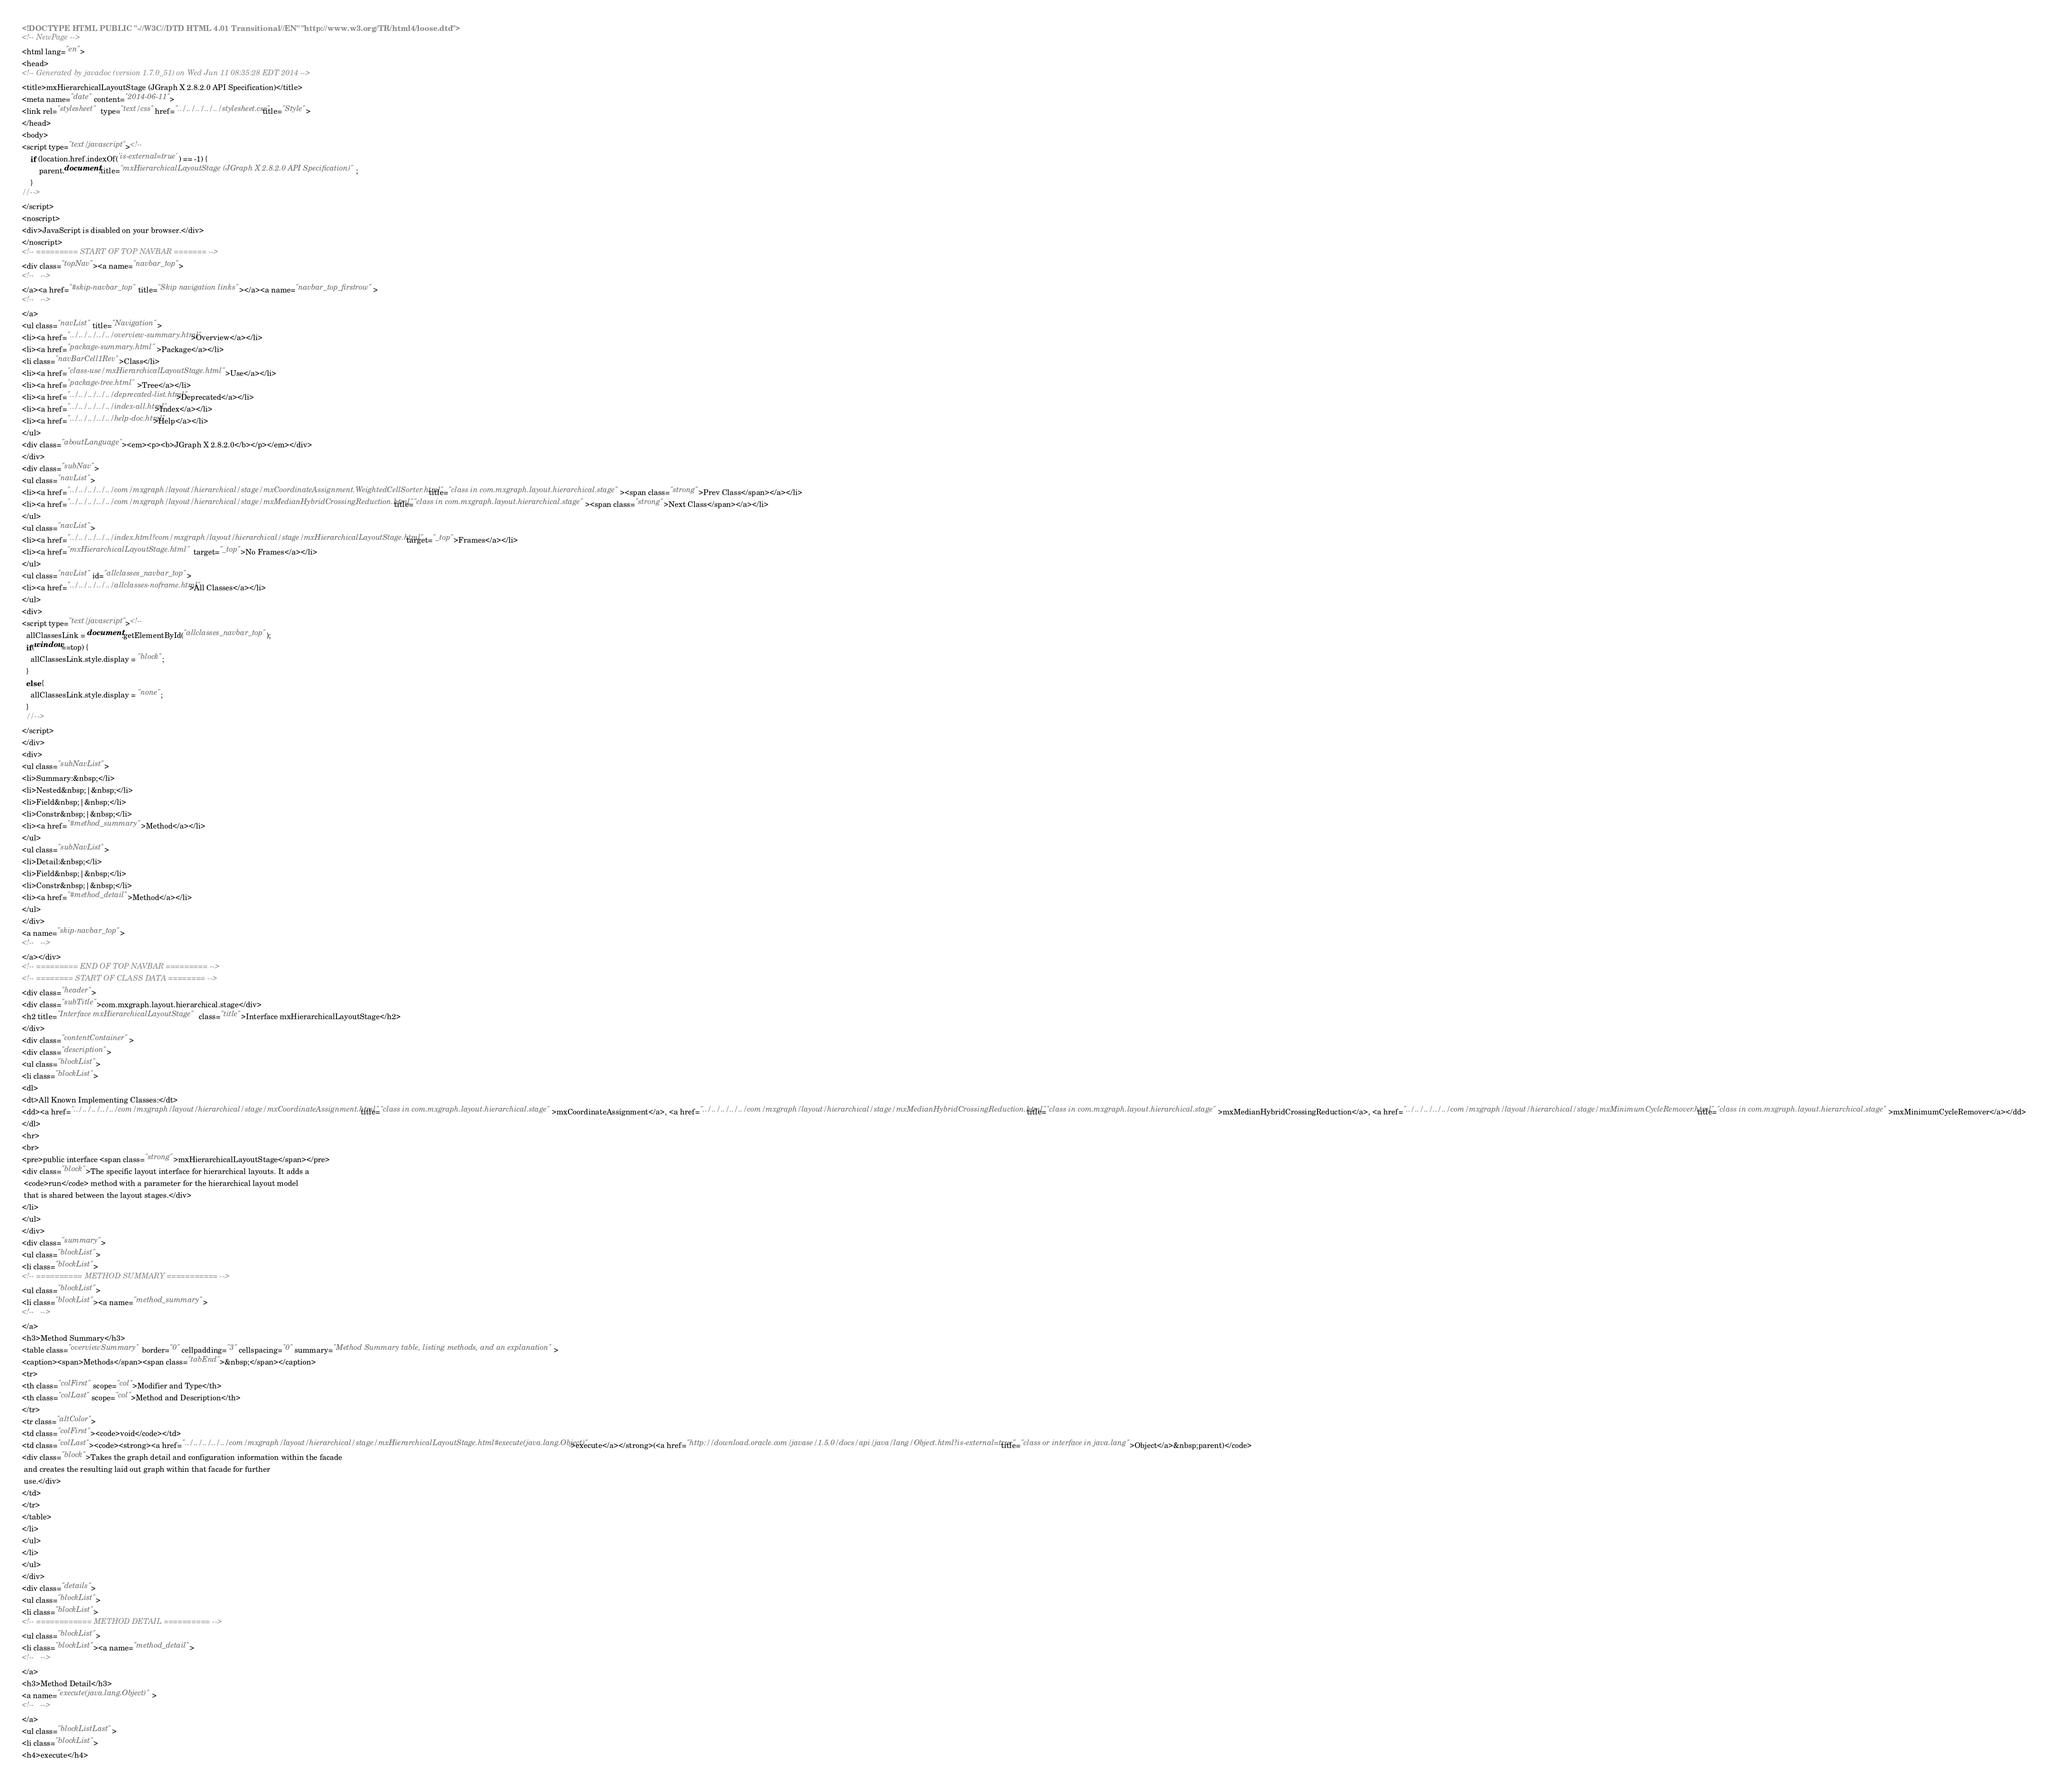Convert code to text. <code><loc_0><loc_0><loc_500><loc_500><_HTML_><!DOCTYPE HTML PUBLIC "-//W3C//DTD HTML 4.01 Transitional//EN" "http://www.w3.org/TR/html4/loose.dtd">
<!-- NewPage -->
<html lang="en">
<head>
<!-- Generated by javadoc (version 1.7.0_51) on Wed Jun 11 08:35:28 EDT 2014 -->
<title>mxHierarchicalLayoutStage (JGraph X 2.8.2.0 API Specification)</title>
<meta name="date" content="2014-06-11">
<link rel="stylesheet" type="text/css" href="../../../../../stylesheet.css" title="Style">
</head>
<body>
<script type="text/javascript"><!--
    if (location.href.indexOf('is-external=true') == -1) {
        parent.document.title="mxHierarchicalLayoutStage (JGraph X 2.8.2.0 API Specification)";
    }
//-->
</script>
<noscript>
<div>JavaScript is disabled on your browser.</div>
</noscript>
<!-- ========= START OF TOP NAVBAR ======= -->
<div class="topNav"><a name="navbar_top">
<!--   -->
</a><a href="#skip-navbar_top" title="Skip navigation links"></a><a name="navbar_top_firstrow">
<!--   -->
</a>
<ul class="navList" title="Navigation">
<li><a href="../../../../../overview-summary.html">Overview</a></li>
<li><a href="package-summary.html">Package</a></li>
<li class="navBarCell1Rev">Class</li>
<li><a href="class-use/mxHierarchicalLayoutStage.html">Use</a></li>
<li><a href="package-tree.html">Tree</a></li>
<li><a href="../../../../../deprecated-list.html">Deprecated</a></li>
<li><a href="../../../../../index-all.html">Index</a></li>
<li><a href="../../../../../help-doc.html">Help</a></li>
</ul>
<div class="aboutLanguage"><em><p><b>JGraph X 2.8.2.0</b></p></em></div>
</div>
<div class="subNav">
<ul class="navList">
<li><a href="../../../../../com/mxgraph/layout/hierarchical/stage/mxCoordinateAssignment.WeightedCellSorter.html" title="class in com.mxgraph.layout.hierarchical.stage"><span class="strong">Prev Class</span></a></li>
<li><a href="../../../../../com/mxgraph/layout/hierarchical/stage/mxMedianHybridCrossingReduction.html" title="class in com.mxgraph.layout.hierarchical.stage"><span class="strong">Next Class</span></a></li>
</ul>
<ul class="navList">
<li><a href="../../../../../index.html?com/mxgraph/layout/hierarchical/stage/mxHierarchicalLayoutStage.html" target="_top">Frames</a></li>
<li><a href="mxHierarchicalLayoutStage.html" target="_top">No Frames</a></li>
</ul>
<ul class="navList" id="allclasses_navbar_top">
<li><a href="../../../../../allclasses-noframe.html">All Classes</a></li>
</ul>
<div>
<script type="text/javascript"><!--
  allClassesLink = document.getElementById("allclasses_navbar_top");
  if(window==top) {
    allClassesLink.style.display = "block";
  }
  else {
    allClassesLink.style.display = "none";
  }
  //-->
</script>
</div>
<div>
<ul class="subNavList">
<li>Summary:&nbsp;</li>
<li>Nested&nbsp;|&nbsp;</li>
<li>Field&nbsp;|&nbsp;</li>
<li>Constr&nbsp;|&nbsp;</li>
<li><a href="#method_summary">Method</a></li>
</ul>
<ul class="subNavList">
<li>Detail:&nbsp;</li>
<li>Field&nbsp;|&nbsp;</li>
<li>Constr&nbsp;|&nbsp;</li>
<li><a href="#method_detail">Method</a></li>
</ul>
</div>
<a name="skip-navbar_top">
<!--   -->
</a></div>
<!-- ========= END OF TOP NAVBAR ========= -->
<!-- ======== START OF CLASS DATA ======== -->
<div class="header">
<div class="subTitle">com.mxgraph.layout.hierarchical.stage</div>
<h2 title="Interface mxHierarchicalLayoutStage" class="title">Interface mxHierarchicalLayoutStage</h2>
</div>
<div class="contentContainer">
<div class="description">
<ul class="blockList">
<li class="blockList">
<dl>
<dt>All Known Implementing Classes:</dt>
<dd><a href="../../../../../com/mxgraph/layout/hierarchical/stage/mxCoordinateAssignment.html" title="class in com.mxgraph.layout.hierarchical.stage">mxCoordinateAssignment</a>, <a href="../../../../../com/mxgraph/layout/hierarchical/stage/mxMedianHybridCrossingReduction.html" title="class in com.mxgraph.layout.hierarchical.stage">mxMedianHybridCrossingReduction</a>, <a href="../../../../../com/mxgraph/layout/hierarchical/stage/mxMinimumCycleRemover.html" title="class in com.mxgraph.layout.hierarchical.stage">mxMinimumCycleRemover</a></dd>
</dl>
<hr>
<br>
<pre>public interface <span class="strong">mxHierarchicalLayoutStage</span></pre>
<div class="block">The specific layout interface for hierarchical layouts. It adds a
 <code>run</code> method with a parameter for the hierarchical layout model
 that is shared between the layout stages.</div>
</li>
</ul>
</div>
<div class="summary">
<ul class="blockList">
<li class="blockList">
<!-- ========== METHOD SUMMARY =========== -->
<ul class="blockList">
<li class="blockList"><a name="method_summary">
<!--   -->
</a>
<h3>Method Summary</h3>
<table class="overviewSummary" border="0" cellpadding="3" cellspacing="0" summary="Method Summary table, listing methods, and an explanation">
<caption><span>Methods</span><span class="tabEnd">&nbsp;</span></caption>
<tr>
<th class="colFirst" scope="col">Modifier and Type</th>
<th class="colLast" scope="col">Method and Description</th>
</tr>
<tr class="altColor">
<td class="colFirst"><code>void</code></td>
<td class="colLast"><code><strong><a href="../../../../../com/mxgraph/layout/hierarchical/stage/mxHierarchicalLayoutStage.html#execute(java.lang.Object)">execute</a></strong>(<a href="http://download.oracle.com/javase/1.5.0/docs/api/java/lang/Object.html?is-external=true" title="class or interface in java.lang">Object</a>&nbsp;parent)</code>
<div class="block">Takes the graph detail and configuration information within the facade
 and creates the resulting laid out graph within that facade for further
 use.</div>
</td>
</tr>
</table>
</li>
</ul>
</li>
</ul>
</div>
<div class="details">
<ul class="blockList">
<li class="blockList">
<!-- ============ METHOD DETAIL ========== -->
<ul class="blockList">
<li class="blockList"><a name="method_detail">
<!--   -->
</a>
<h3>Method Detail</h3>
<a name="execute(java.lang.Object)">
<!--   -->
</a>
<ul class="blockListLast">
<li class="blockList">
<h4>execute</h4></code> 